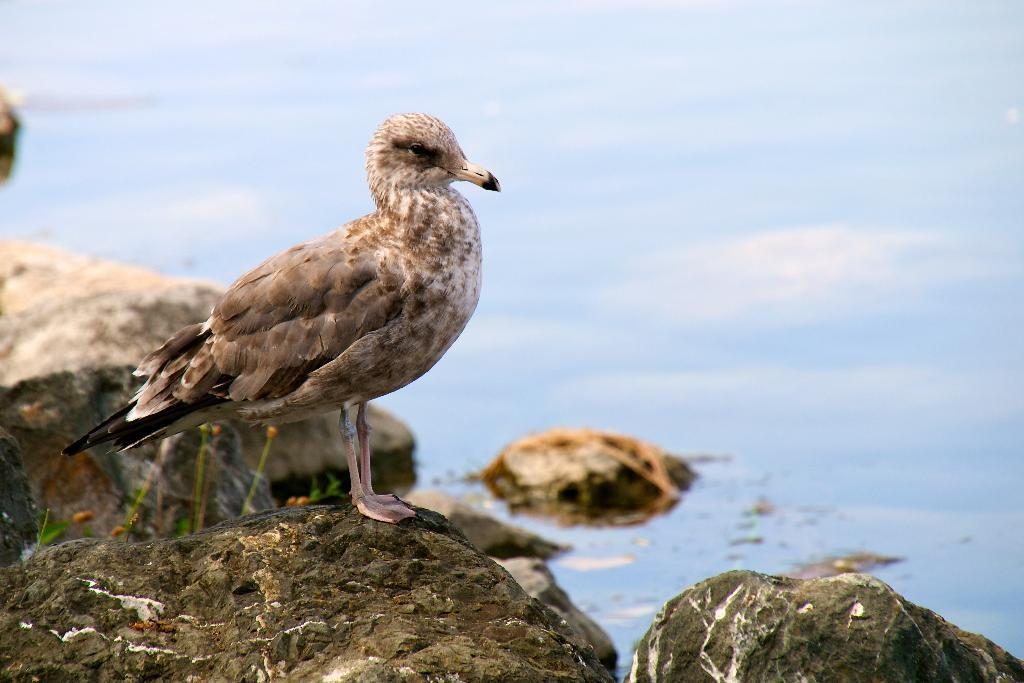What can be seen in the foreground of the image? In the foreground of the image, there are rocks, a plant, and a bird. Can you describe the plant in the foreground? The plant in the foreground is not described in detail, but it is present alongside the rocks and bird. What is visible in the background of the image? In the background of the image, there is a water body. What type of cart is being pulled by the bird in the image? There is no cart present in the image, and the bird is not pulling anything. 